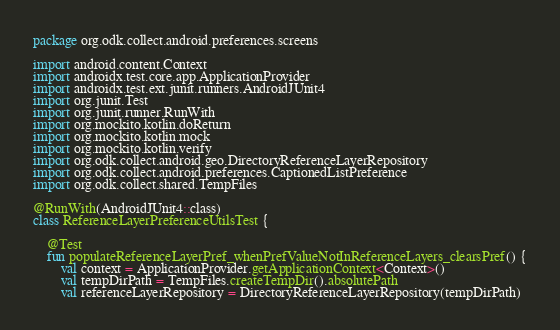Convert code to text. <code><loc_0><loc_0><loc_500><loc_500><_Kotlin_>package org.odk.collect.android.preferences.screens

import android.content.Context
import androidx.test.core.app.ApplicationProvider
import androidx.test.ext.junit.runners.AndroidJUnit4
import org.junit.Test
import org.junit.runner.RunWith
import org.mockito.kotlin.doReturn
import org.mockito.kotlin.mock
import org.mockito.kotlin.verify
import org.odk.collect.android.geo.DirectoryReferenceLayerRepository
import org.odk.collect.android.preferences.CaptionedListPreference
import org.odk.collect.shared.TempFiles

@RunWith(AndroidJUnit4::class)
class ReferenceLayerPreferenceUtilsTest {

    @Test
    fun populateReferenceLayerPref_whenPrefValueNotInReferenceLayers_clearsPref() {
        val context = ApplicationProvider.getApplicationContext<Context>()
        val tempDirPath = TempFiles.createTempDir().absolutePath
        val referenceLayerRepository = DirectoryReferenceLayerRepository(tempDirPath)
</code> 